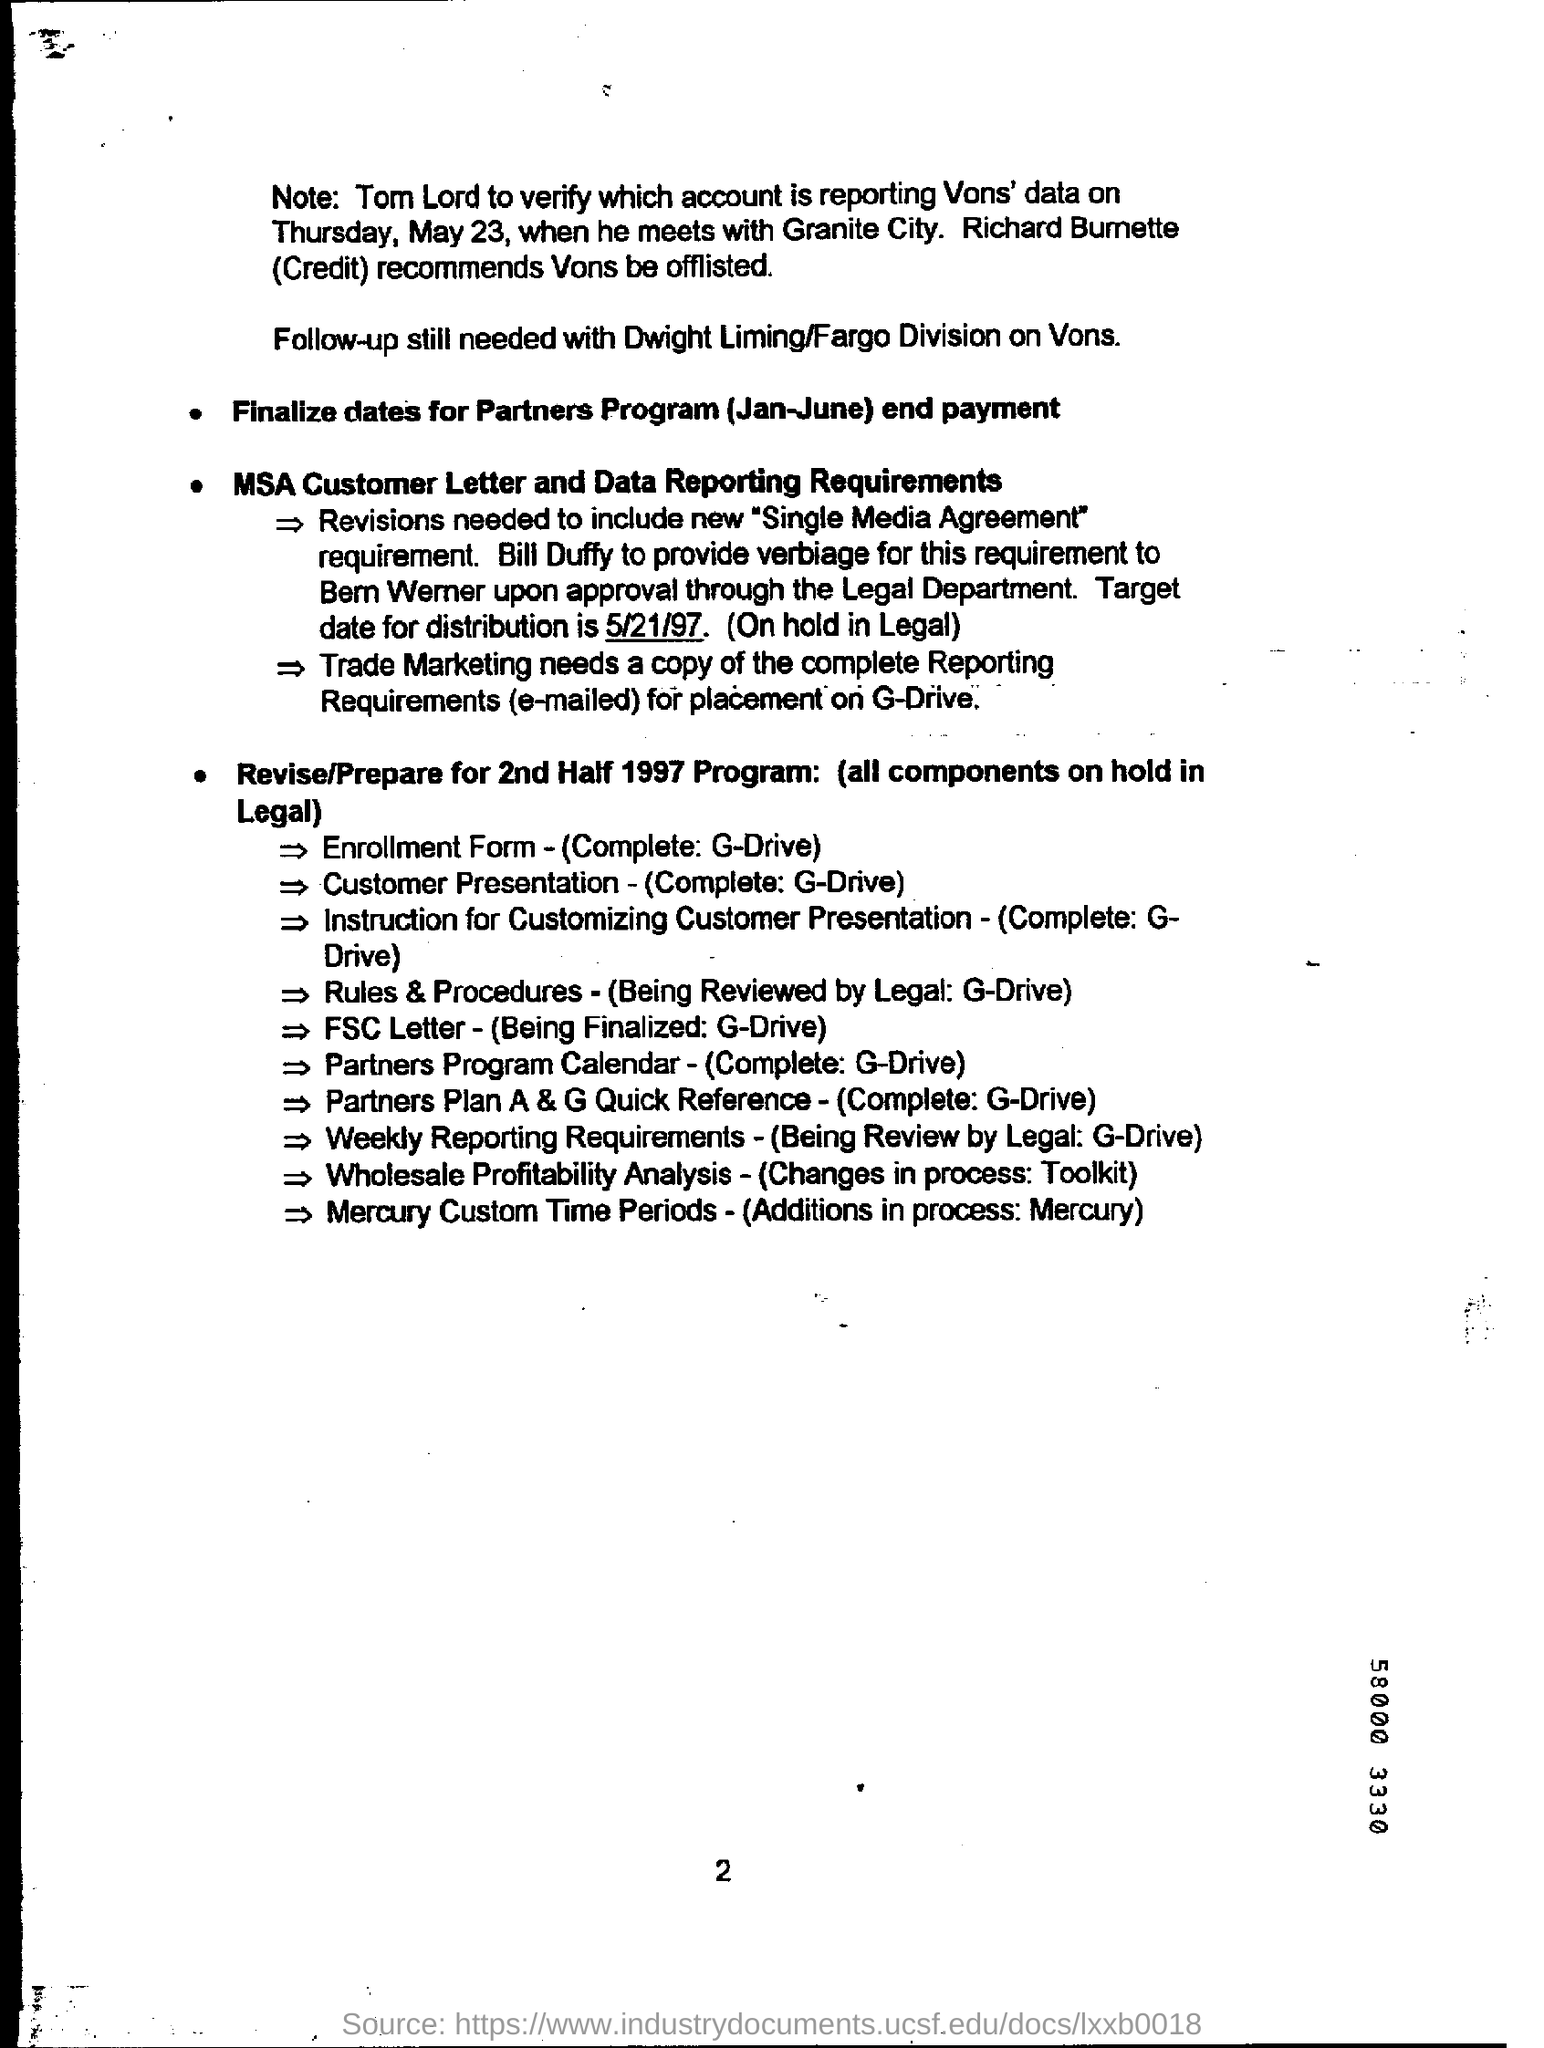Point out several critical features in this image. Who recommends that Vans be offlisted? Richard Bumette does. The target date for the distribution is May 21, 1997. 